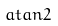<formula> <loc_0><loc_0><loc_500><loc_500>a t a n 2</formula> 